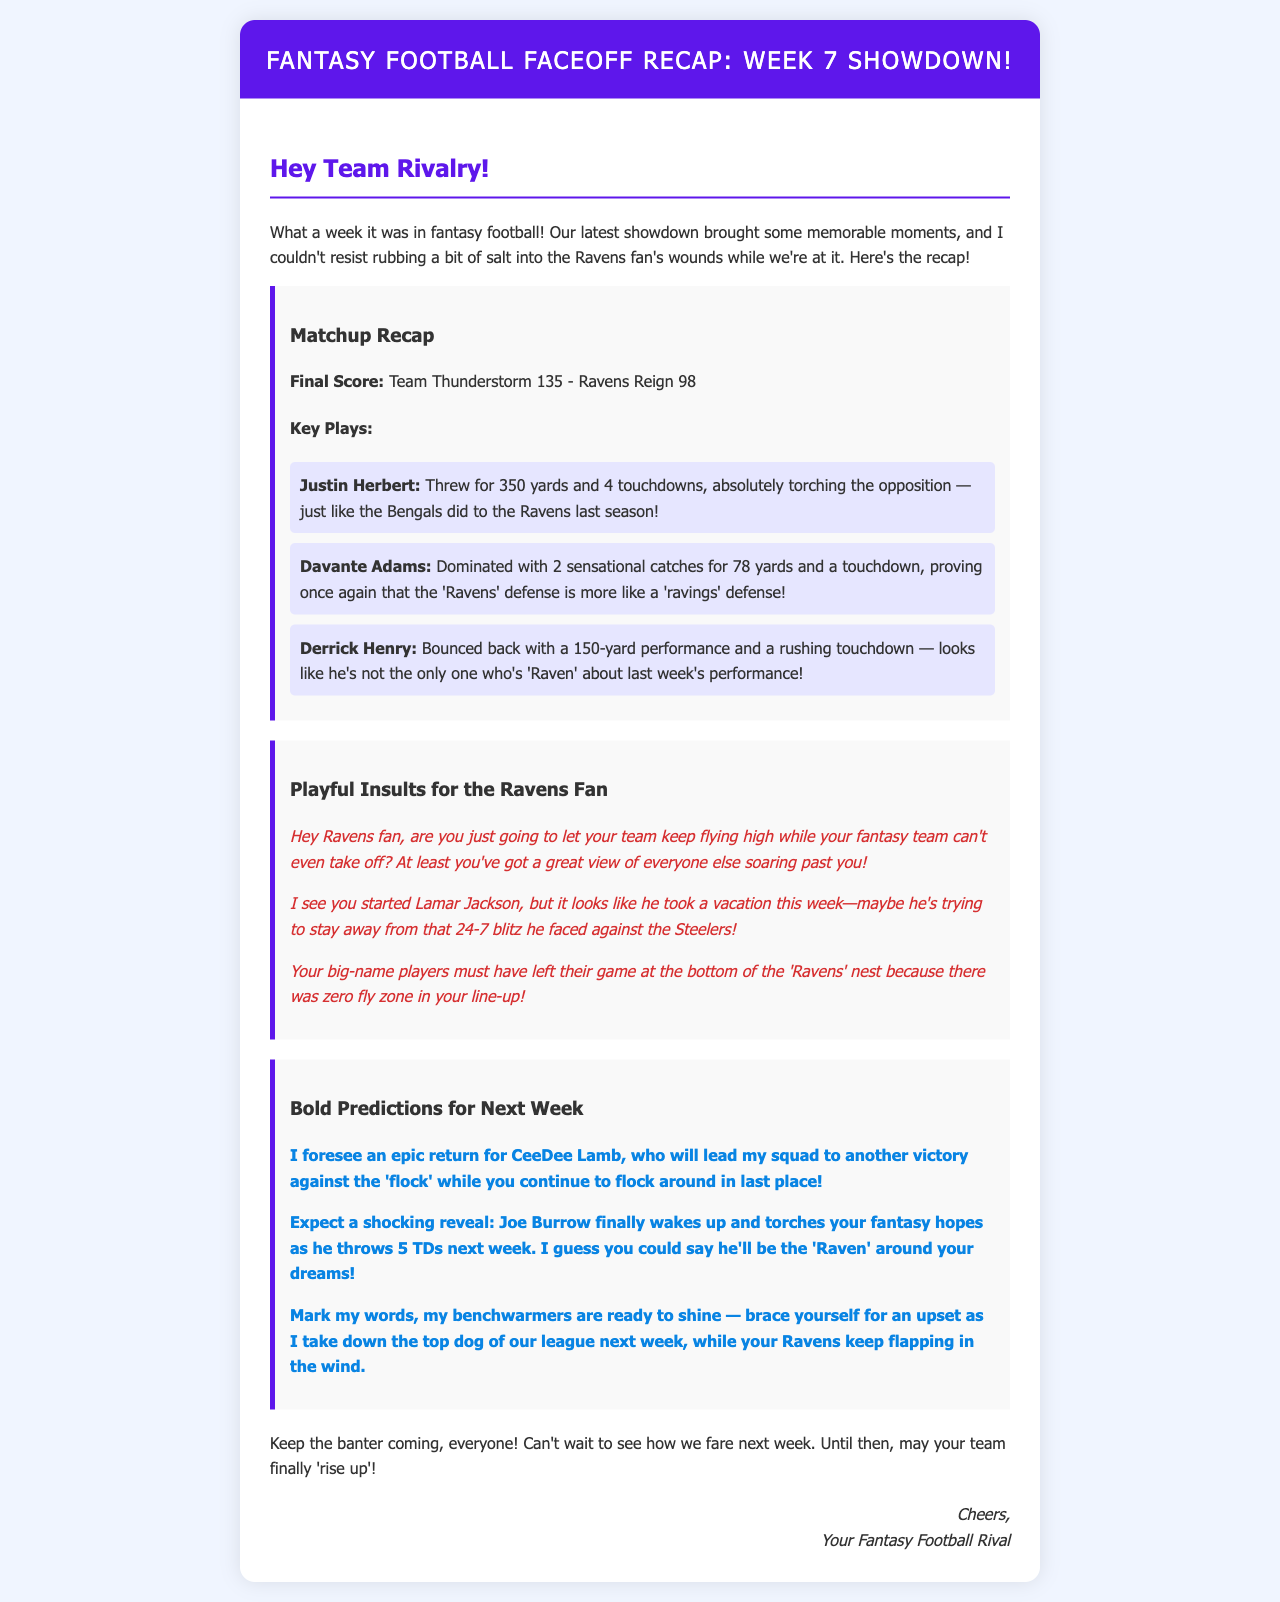What was the final score of the matchup? The final score is stated in the document under Matchup Recap, where Team Thunderstorm scored 135 and Ravens Reign scored 98.
Answer: Team Thunderstorm 135 - Ravens Reign 98 Who had the key play of throwing for 350 yards? The document lists Justin Herbert as the player who threw for 350 yards under Key Plays.
Answer: Justin Herbert What key play is associated with Davante Adams? The document mentions that Davante Adams made 2 catches for 78 yards and a touchdown.
Answer: 2 catches for 78 yards and a touchdown How many touchdowns did Joe Burrow predict to throw next week? The document contains a prediction mentioning Joe Burrow throwing 5 touchdowns next week.
Answer: 5 TDs What is the playful insult about Lamar Jackson's performance? The document refers to Lamar Jackson taking a vacation during the week.
Answer: He took a vacation Which player is expected to help lead to victory in the bold predictions? CeeDee Lamb is mentioned as leading the squad to victory in the bold predictions.
Answer: CeeDee Lamb What color is used for the header background? The document describes the header background color as #5e17eb.
Answer: #5e17eb What type of document is presented? The document is a recap of a fantasy football matchup week.
Answer: recap of a fantasy football matchup 